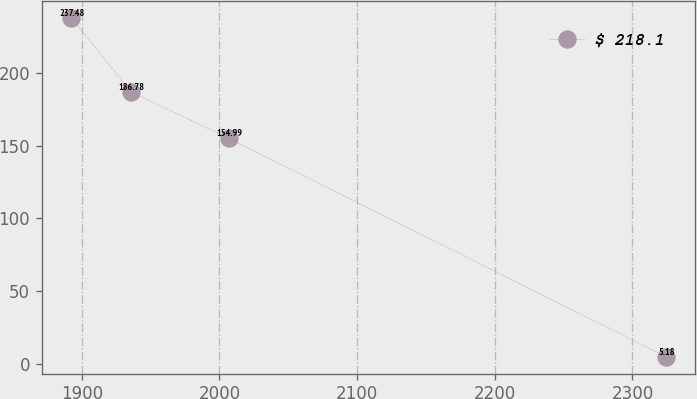Convert chart. <chart><loc_0><loc_0><loc_500><loc_500><line_chart><ecel><fcel>$ 218.1<nl><fcel>1892.53<fcel>237.48<nl><fcel>1935.69<fcel>186.78<nl><fcel>2006.74<fcel>154.99<nl><fcel>2324.16<fcel>5.18<nl></chart> 